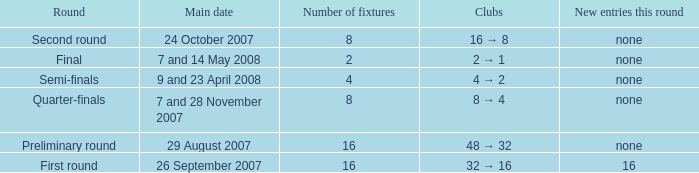What is the Round when the number of fixtures is more than 2, and the Main date of 7 and 28 november 2007? Quarter-finals. 